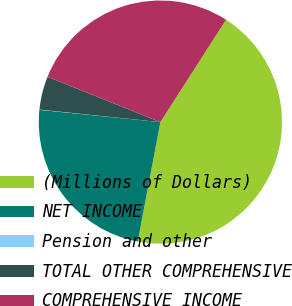Convert chart to OTSL. <chart><loc_0><loc_0><loc_500><loc_500><pie_chart><fcel>(Millions of Dollars)<fcel>NET INCOME<fcel>Pension and other<fcel>TOTAL OTHER COMPREHENSIVE<fcel>COMPREHENSIVE INCOME<nl><fcel>43.9%<fcel>23.62%<fcel>0.04%<fcel>4.43%<fcel>28.0%<nl></chart> 